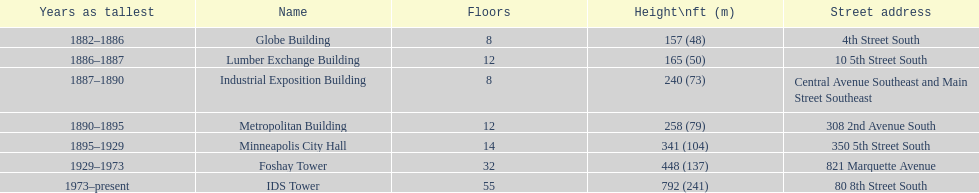Which buildings have the same number of floors as another building? Globe Building, Lumber Exchange Building, Industrial Exposition Building, Metropolitan Building. Of those, which has the same as the lumber exchange building? Metropolitan Building. 